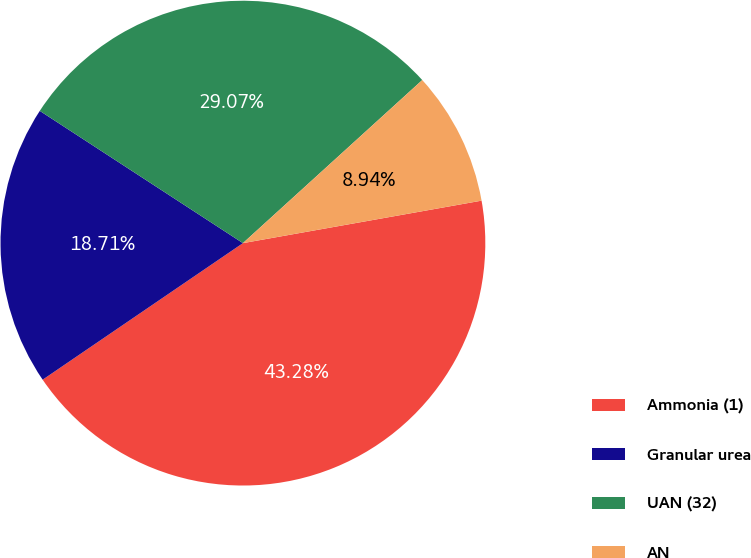Convert chart to OTSL. <chart><loc_0><loc_0><loc_500><loc_500><pie_chart><fcel>Ammonia (1)<fcel>Granular urea<fcel>UAN (32)<fcel>AN<nl><fcel>43.28%<fcel>18.71%<fcel>29.07%<fcel>8.94%<nl></chart> 